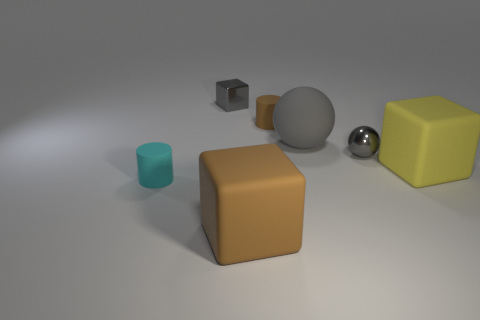Is the large brown thing made of the same material as the yellow block?
Your answer should be compact. Yes. Are there any large gray objects behind the tiny cyan rubber cylinder?
Provide a succinct answer. Yes. What material is the gray object that is to the right of the large gray ball that is behind the cyan cylinder?
Your answer should be very brief. Metal. The brown matte thing that is the same shape as the yellow thing is what size?
Provide a short and direct response. Large. What is the color of the tiny thing that is both behind the gray metal ball and to the right of the large brown thing?
Your response must be concise. Brown. Is the size of the rubber cylinder to the right of the brown block the same as the yellow rubber object?
Keep it short and to the point. No. Are the small brown thing and the small cylinder in front of the large matte sphere made of the same material?
Offer a very short reply. Yes. What number of green things are tiny objects or small metal balls?
Give a very brief answer. 0. Are there any big balls?
Your answer should be compact. Yes. There is a small metallic thing on the right side of the matte block that is left of the tiny sphere; are there any tiny objects behind it?
Make the answer very short. Yes. 